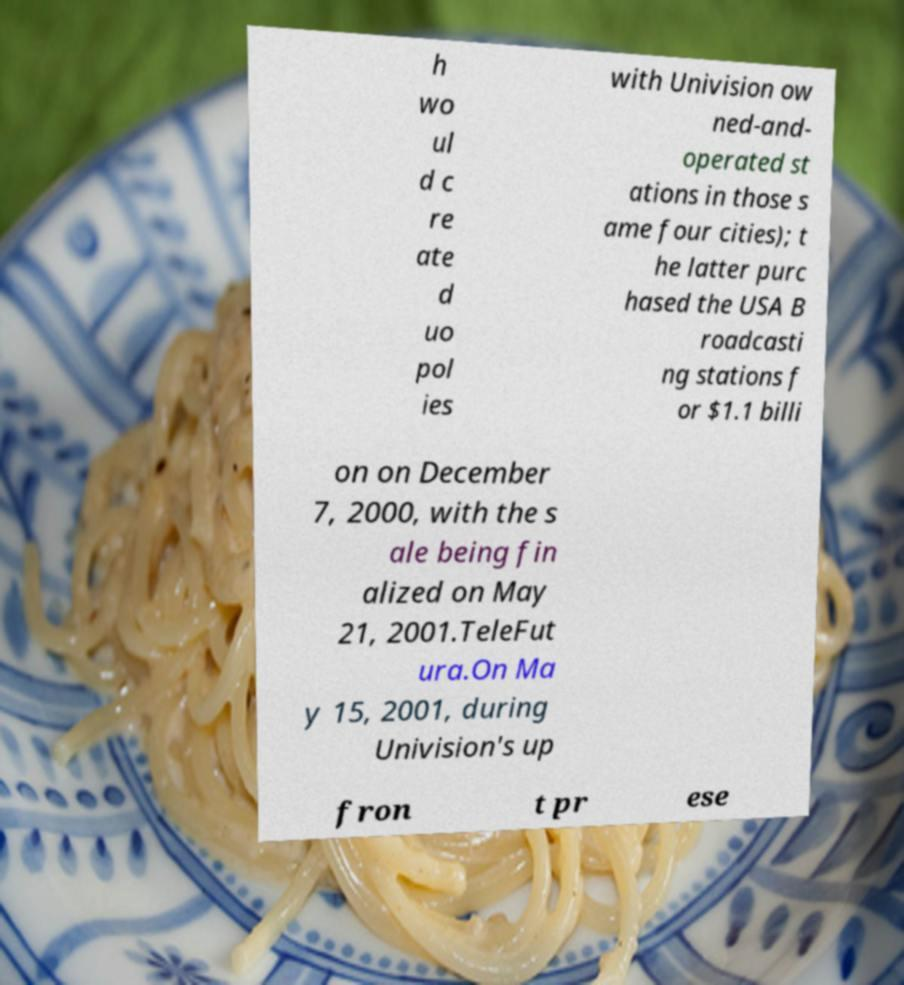What messages or text are displayed in this image? I need them in a readable, typed format. h wo ul d c re ate d uo pol ies with Univision ow ned-and- operated st ations in those s ame four cities); t he latter purc hased the USA B roadcasti ng stations f or $1.1 billi on on December 7, 2000, with the s ale being fin alized on May 21, 2001.TeleFut ura.On Ma y 15, 2001, during Univision's up fron t pr ese 